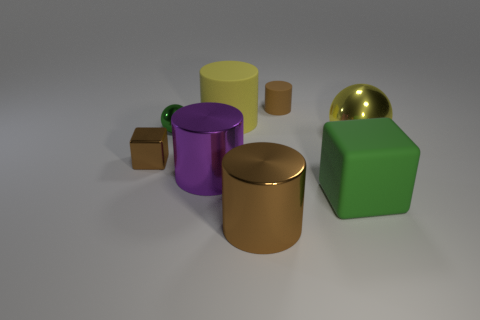Subtract 1 cylinders. How many cylinders are left? 3 Subtract all cyan balls. Subtract all green cylinders. How many balls are left? 2 Add 2 big shiny spheres. How many objects exist? 10 Subtract all spheres. How many objects are left? 6 Add 8 large green cubes. How many large green cubes are left? 9 Add 5 tiny brown blocks. How many tiny brown blocks exist? 6 Subtract 0 red spheres. How many objects are left? 8 Subtract all big metal objects. Subtract all large yellow shiny objects. How many objects are left? 4 